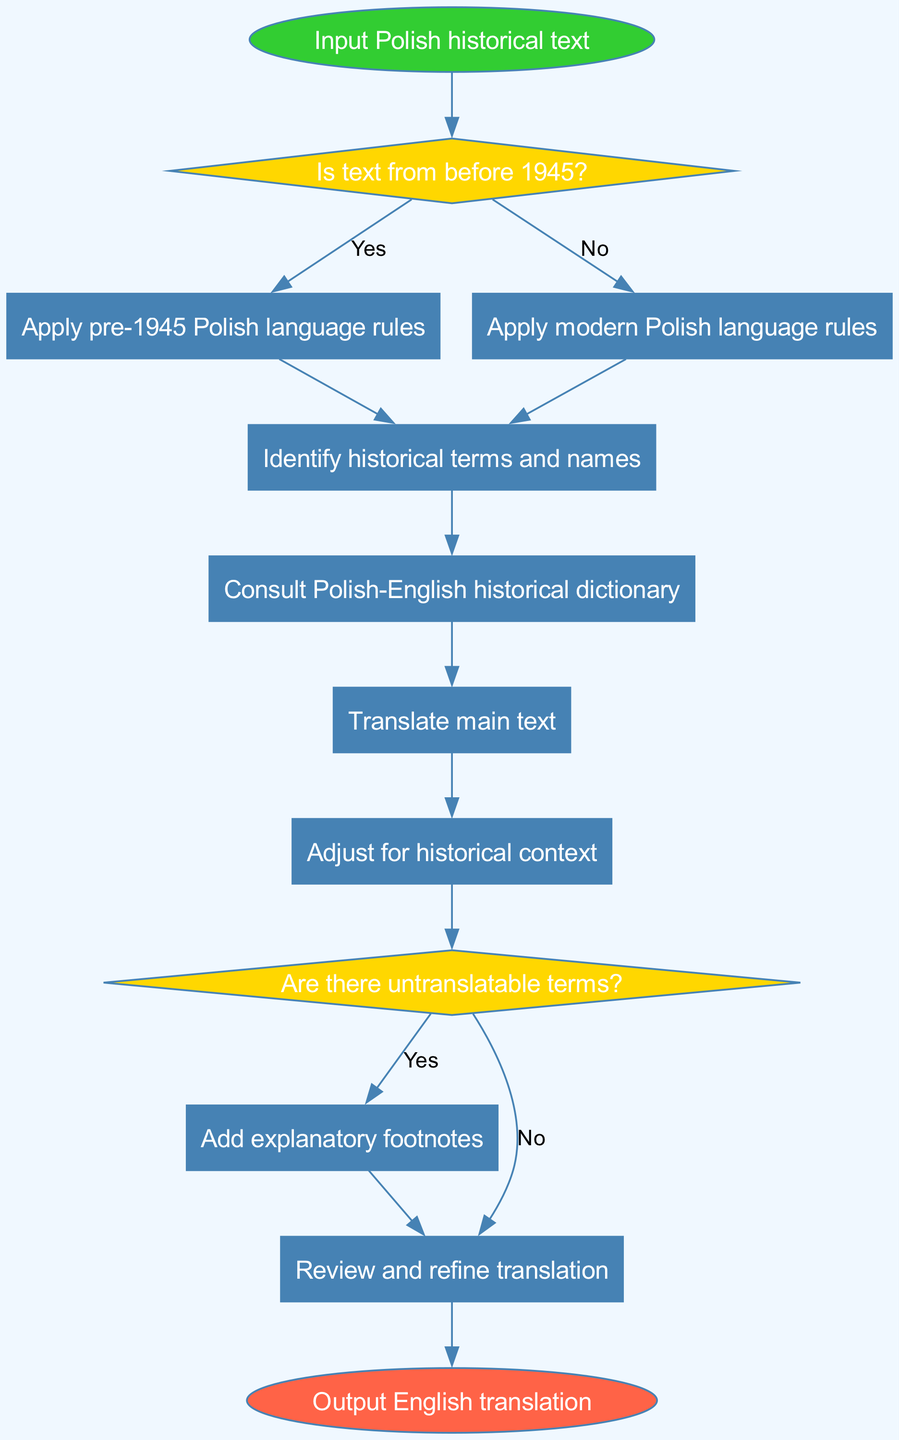What is the first step in the flowchart? The flowchart begins with the input of the Polish historical text, which is represented as the first node labeled "Input Polish historical text."
Answer: Input Polish historical text How many process nodes are in the diagram? There are eight process nodes, labeled from process1 to process8, which are involved in the translation algorithm.
Answer: 8 What decision follows the application of language rules? The decision that follows the application of language rules is whether the text is from before 1945, as indicated by the node labeled "Is text from before 1945?"
Answer: Is text from before 1945? What happens when untranslatable terms are found? When there are untranslatable terms, the flow advances to process7 where explanatory footnotes are added to clarify the translation.
Answer: Add explanatory footnotes What is the final output of the flowchart process? The final output of the process, represented in the end node, is the English translation of the Polish historical text.
Answer: Output English translation What processes are executed when the text is not from before 1945? If the text is not from before 1945, the flowchart directs to process2, "Apply modern Polish language rules," then to process3, "Identify historical terms and names."
Answer: Apply modern Polish language rules; Identify historical terms and names Which process incorporates historical context adjustments? The process that incorporates adjustments for historical context is labeled as process6, "Adjust for historical context."
Answer: Adjust for historical context What is the relationship between decision node 2 and process node 7? The relationship indicates that if there are untranslatable terms (decision node 2), it directs to process node 7, which states "Add explanatory footnotes," when the answer is yes.
Answer: Yes What decision is made after translating the main text? After translating the main text, the next decision is whether there are untranslatable terms, as shown in decision node 2.
Answer: Are there untranslatable terms? 